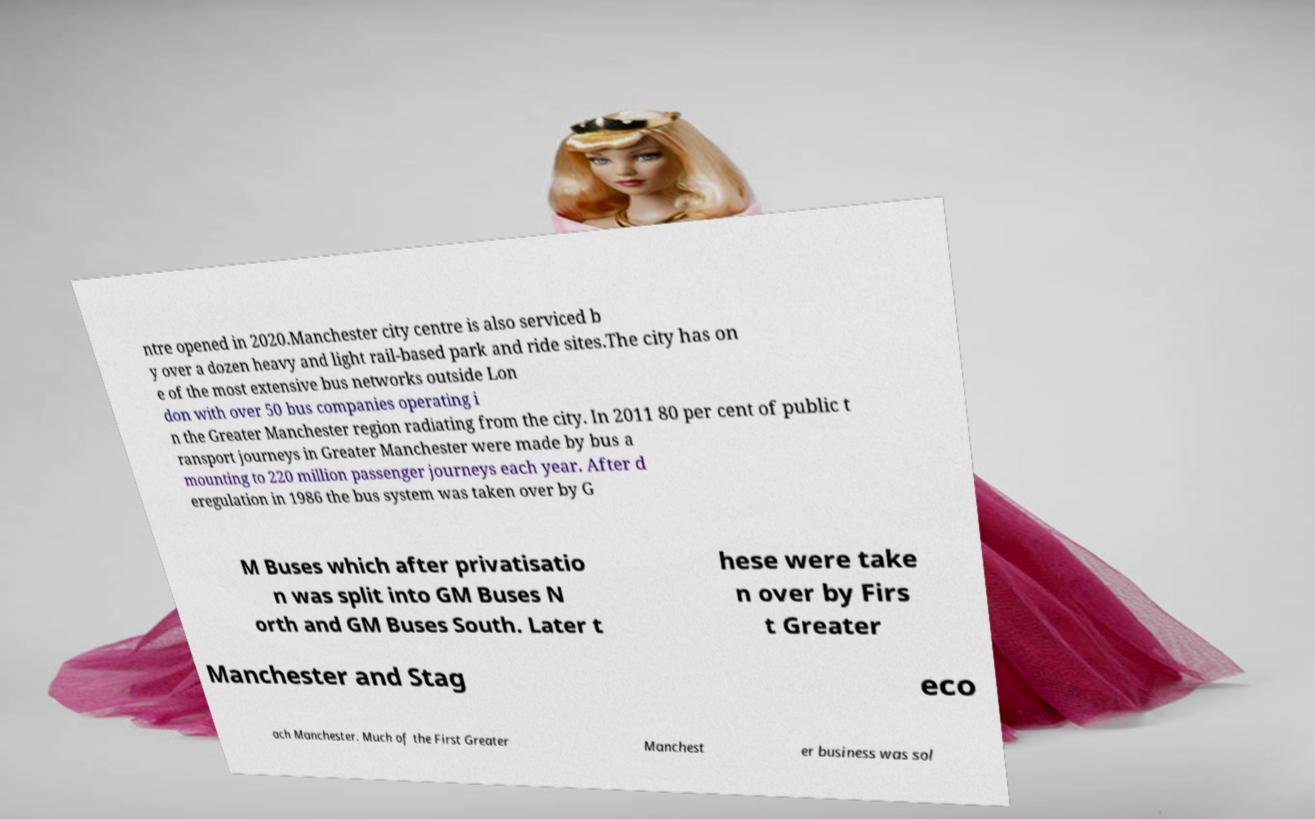Can you accurately transcribe the text from the provided image for me? ntre opened in 2020.Manchester city centre is also serviced b y over a dozen heavy and light rail-based park and ride sites.The city has on e of the most extensive bus networks outside Lon don with over 50 bus companies operating i n the Greater Manchester region radiating from the city. In 2011 80 per cent of public t ransport journeys in Greater Manchester were made by bus a mounting to 220 million passenger journeys each year. After d eregulation in 1986 the bus system was taken over by G M Buses which after privatisatio n was split into GM Buses N orth and GM Buses South. Later t hese were take n over by Firs t Greater Manchester and Stag eco ach Manchester. Much of the First Greater Manchest er business was sol 